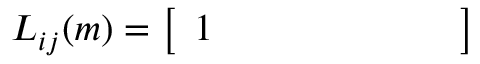<formula> <loc_0><loc_0><loc_500><loc_500>L _ { i j } ( m ) = { \left [ \begin{array} { l l l l l l l } { 1 } \end{array} \right ] }</formula> 